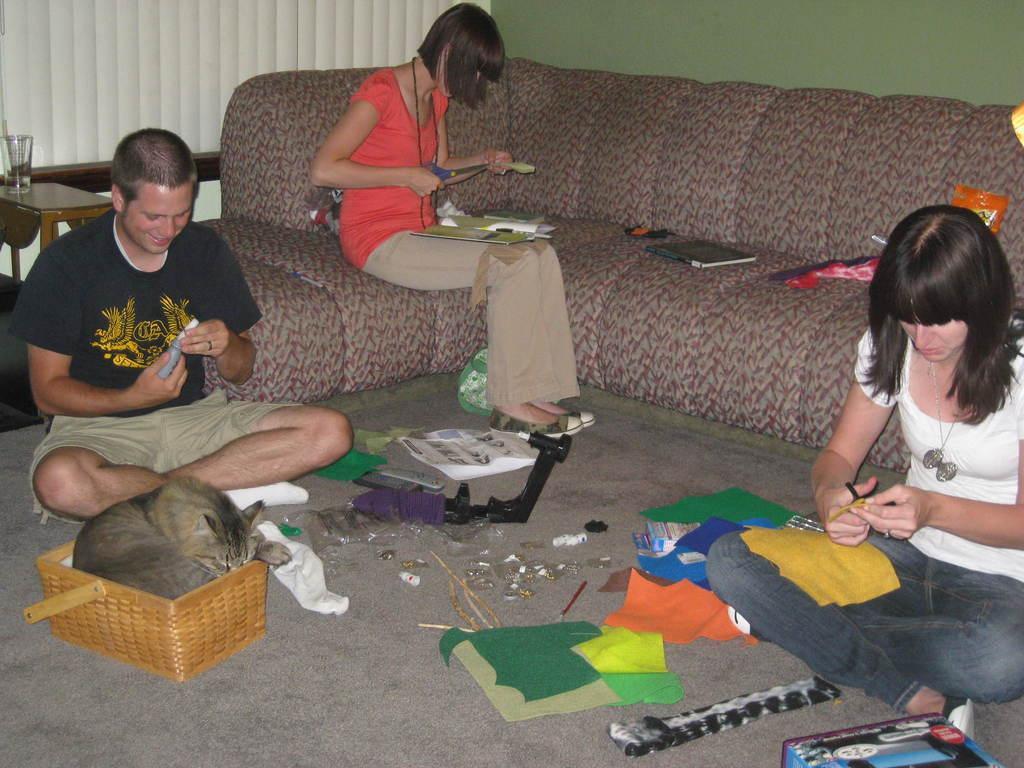How would you summarize this image in a sentence or two? In this picture we can see three people where two are sitting on the floor and a woman sitting on a sofa, books, color papers, cat in a basket, glass on a table and in the background we can see the wall. 